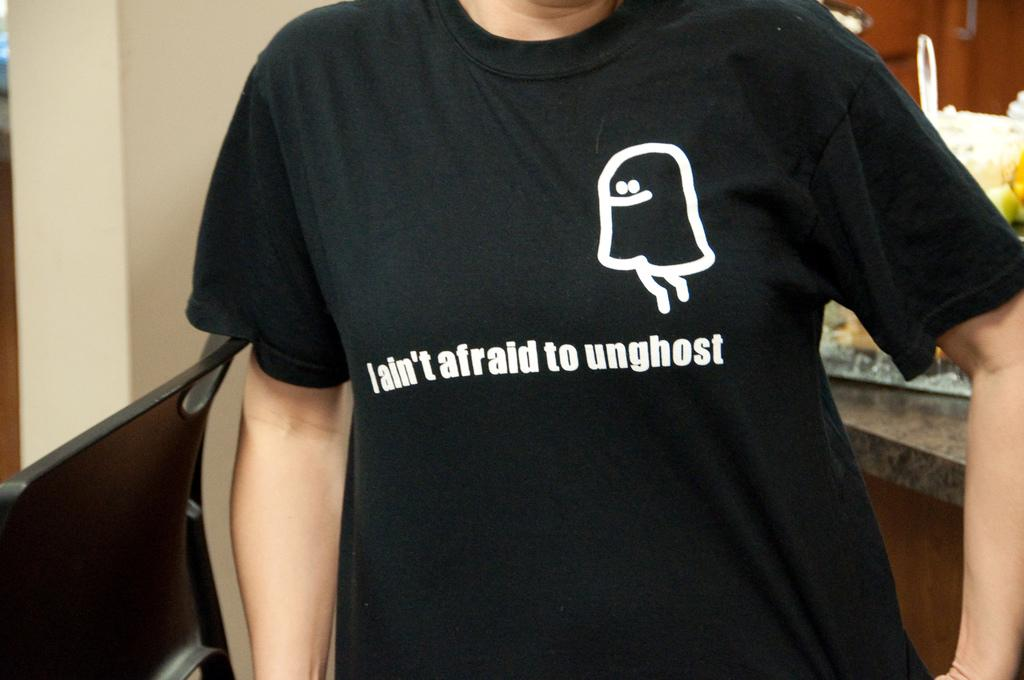<image>
Summarize the visual content of the image. A black shirt that says I ain't afraid to unghost 